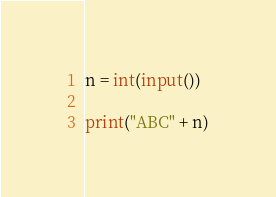Convert code to text. <code><loc_0><loc_0><loc_500><loc_500><_Python_>n = int(input())

print("ABC" + n)</code> 